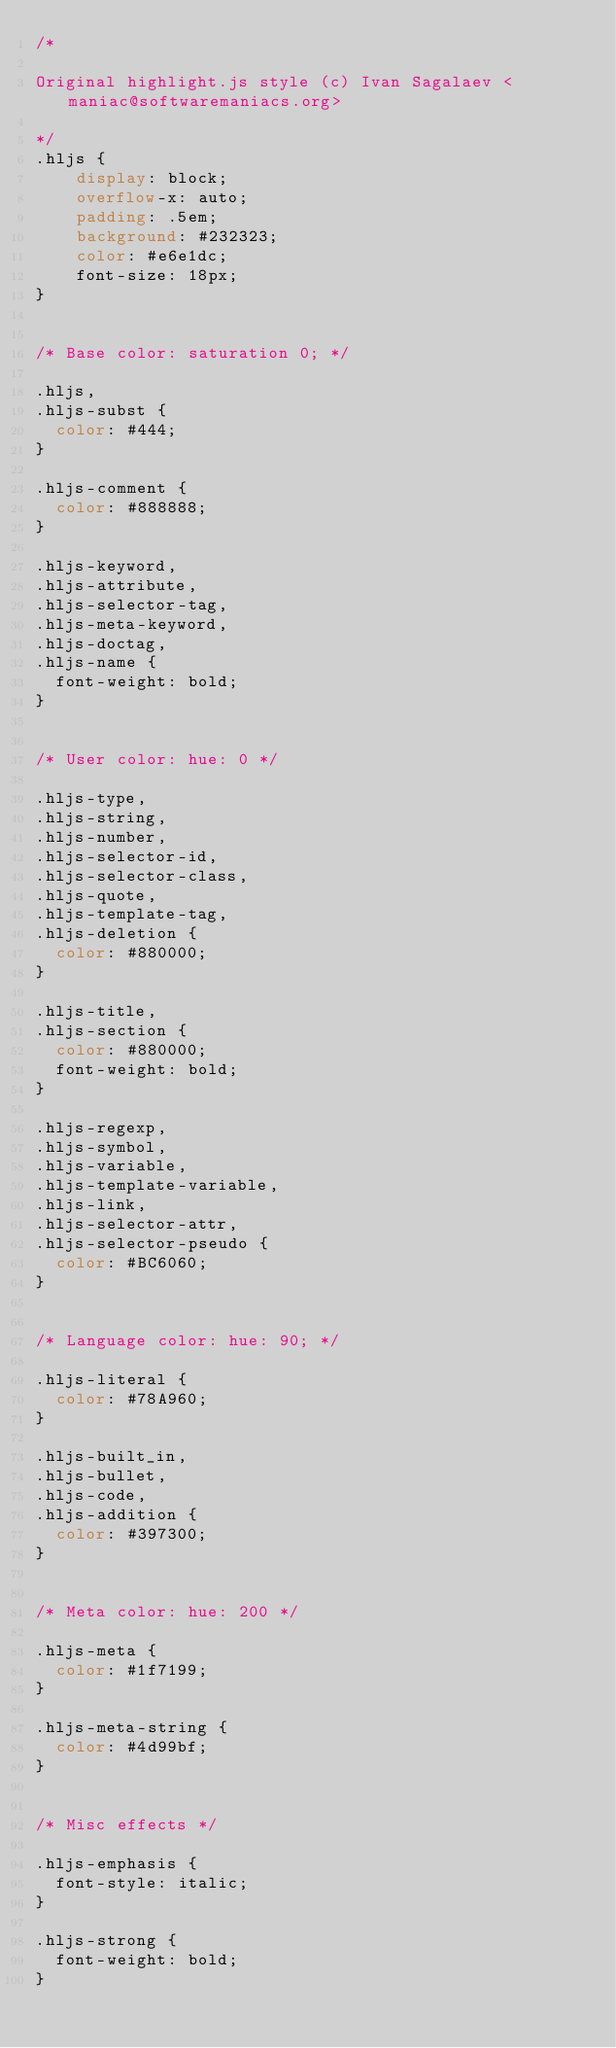<code> <loc_0><loc_0><loc_500><loc_500><_CSS_>/*

Original highlight.js style (c) Ivan Sagalaev <maniac@softwaremaniacs.org>

*/
.hljs {
    display: block;
    overflow-x: auto;
    padding: .5em;
    background: #232323;
    color: #e6e1dc;
    font-size: 18px;
}


/* Base color: saturation 0; */

.hljs,
.hljs-subst {
  color: #444;
}

.hljs-comment {
  color: #888888;
}

.hljs-keyword,
.hljs-attribute,
.hljs-selector-tag,
.hljs-meta-keyword,
.hljs-doctag,
.hljs-name {
  font-weight: bold;
}


/* User color: hue: 0 */

.hljs-type,
.hljs-string,
.hljs-number,
.hljs-selector-id,
.hljs-selector-class,
.hljs-quote,
.hljs-template-tag,
.hljs-deletion {
  color: #880000;
}

.hljs-title,
.hljs-section {
  color: #880000;
  font-weight: bold;
}

.hljs-regexp,
.hljs-symbol,
.hljs-variable,
.hljs-template-variable,
.hljs-link,
.hljs-selector-attr,
.hljs-selector-pseudo {
  color: #BC6060;
}


/* Language color: hue: 90; */

.hljs-literal {
  color: #78A960;
}

.hljs-built_in,
.hljs-bullet,
.hljs-code,
.hljs-addition {
  color: #397300;
}


/* Meta color: hue: 200 */

.hljs-meta {
  color: #1f7199;
}

.hljs-meta-string {
  color: #4d99bf;
}


/* Misc effects */

.hljs-emphasis {
  font-style: italic;
}

.hljs-strong {
  font-weight: bold;
}
</code> 